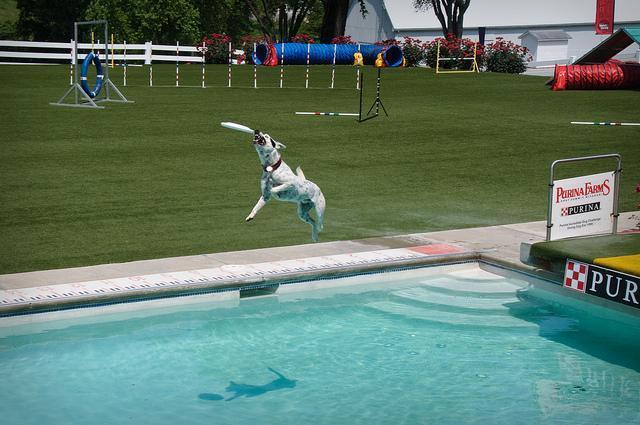How many people have yellow surfboards?
Give a very brief answer. 0. 